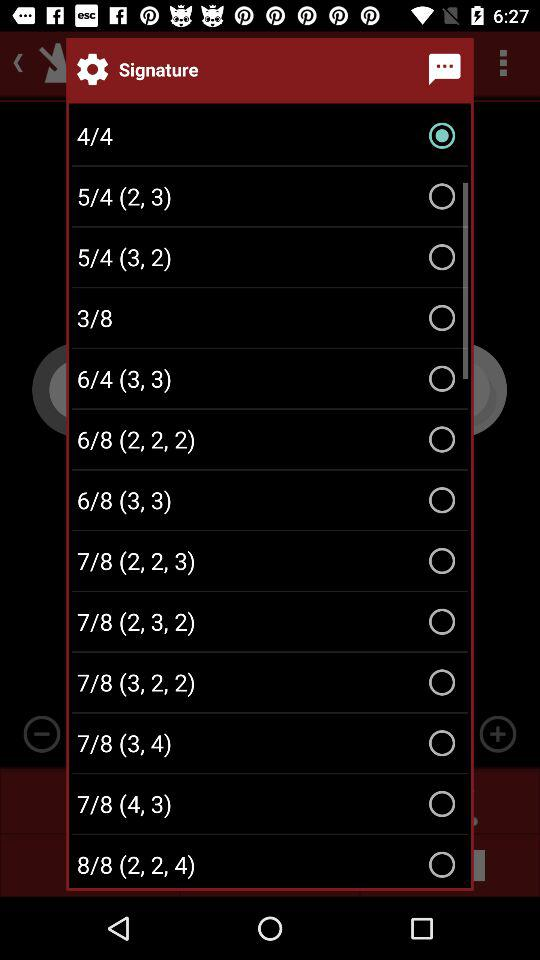Which signature was selected? The selected signature was "4/4". 